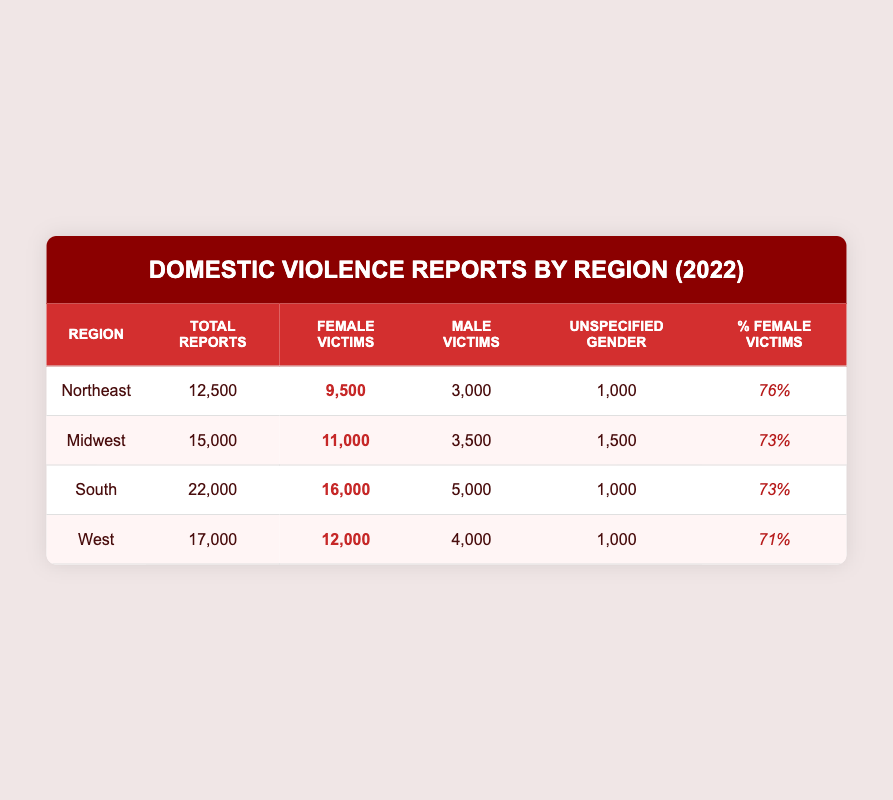What is the total number of domestic violence reports in the South region? The table shows the total reports for each region. For the South region, the value listed under "Total Reports" is 22,000.
Answer: 22,000 What is the number of male victims in the Midwest region? The table indicates that for the Midwest region, the value under "Male Victims" is 3,500.
Answer: 3,500 Which region has the highest percentage of female victims? By comparing the "Percentage Female Victims" column, the Northeast region has the highest percentage at 76%.
Answer: Northeast How many more female victims are there in the South than in the West? In the South, there are 16,000 female victims, and in the West, there are 12,000. The difference is 16,000 - 12,000 = 4,000.
Answer: 4,000 Is it true that the percentage of female victims in the West is greater than in the Midwest? The West has 71% female victims, while the Midwest has 73%. Since 71% is less than 73%, the statement is false.
Answer: No What is the total number of unspecified gender victims across all regions? Adding the unspecified gender values from all regions: 1,000 (Northeast) + 1,500 (Midwest) + 1,000 (South) + 1,000 (West) = 4,500.
Answer: 4,500 What is the average percentage of female victims across all regions? To find the average, add the percentages: 76 + 73 + 73 + 71 = 293, then divide by the number of regions (4): 293/4 = 73.25.
Answer: 73.25 Which region has the lowest total number of reports? By examining the "Total Reports" column, the Northeast region with 12,500 reports is the lowest.
Answer: Northeast If the total reports in the South are 22,000, what percentage of those are male victims? There are 5,000 male victims in the South. To find the percentage, divide the male victims (5,000) by the total reports (22,000) and multiply by 100: (5,000/22,000)*100 ≈ 22.73%.
Answer: 22.73% 